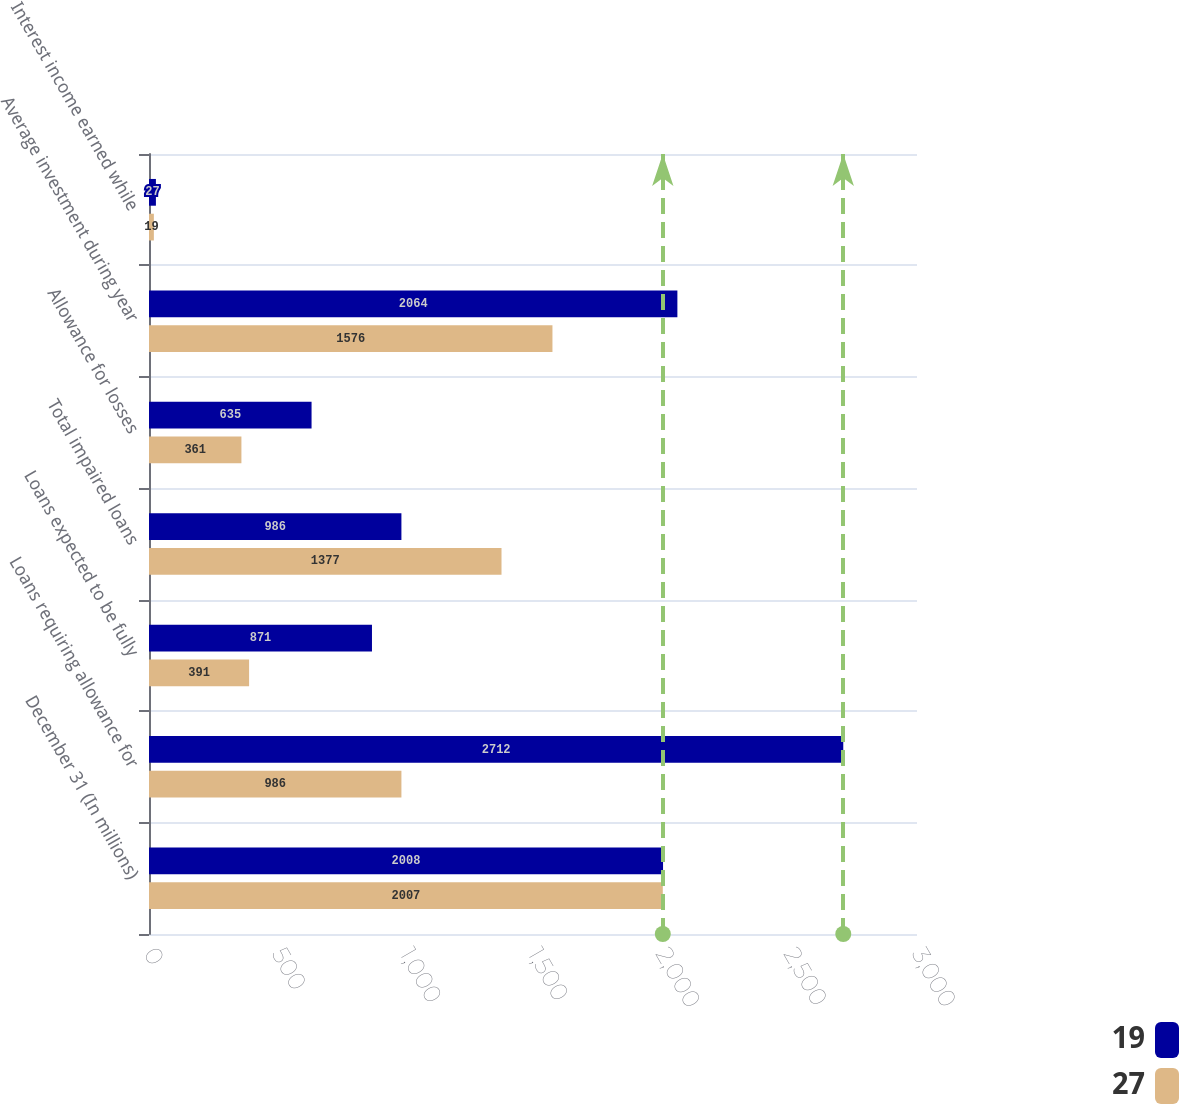Convert chart to OTSL. <chart><loc_0><loc_0><loc_500><loc_500><stacked_bar_chart><ecel><fcel>December 31 (In millions)<fcel>Loans requiring allowance for<fcel>Loans expected to be fully<fcel>Total impaired loans<fcel>Allowance for losses<fcel>Average investment during year<fcel>Interest income earned while<nl><fcel>19<fcel>2008<fcel>2712<fcel>871<fcel>986<fcel>635<fcel>2064<fcel>27<nl><fcel>27<fcel>2007<fcel>986<fcel>391<fcel>1377<fcel>361<fcel>1576<fcel>19<nl></chart> 